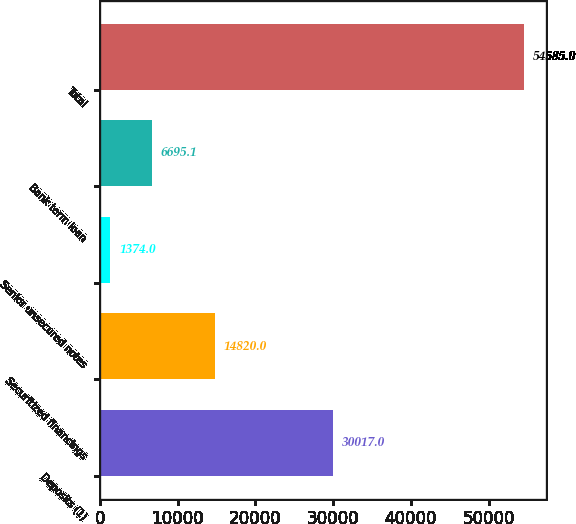Convert chart. <chart><loc_0><loc_0><loc_500><loc_500><bar_chart><fcel>Deposits (1)<fcel>Securitized financings<fcel>Senior unsecured notes<fcel>Bank term loan<fcel>Total<nl><fcel>30017<fcel>14820<fcel>1374<fcel>6695.1<fcel>54585<nl></chart> 